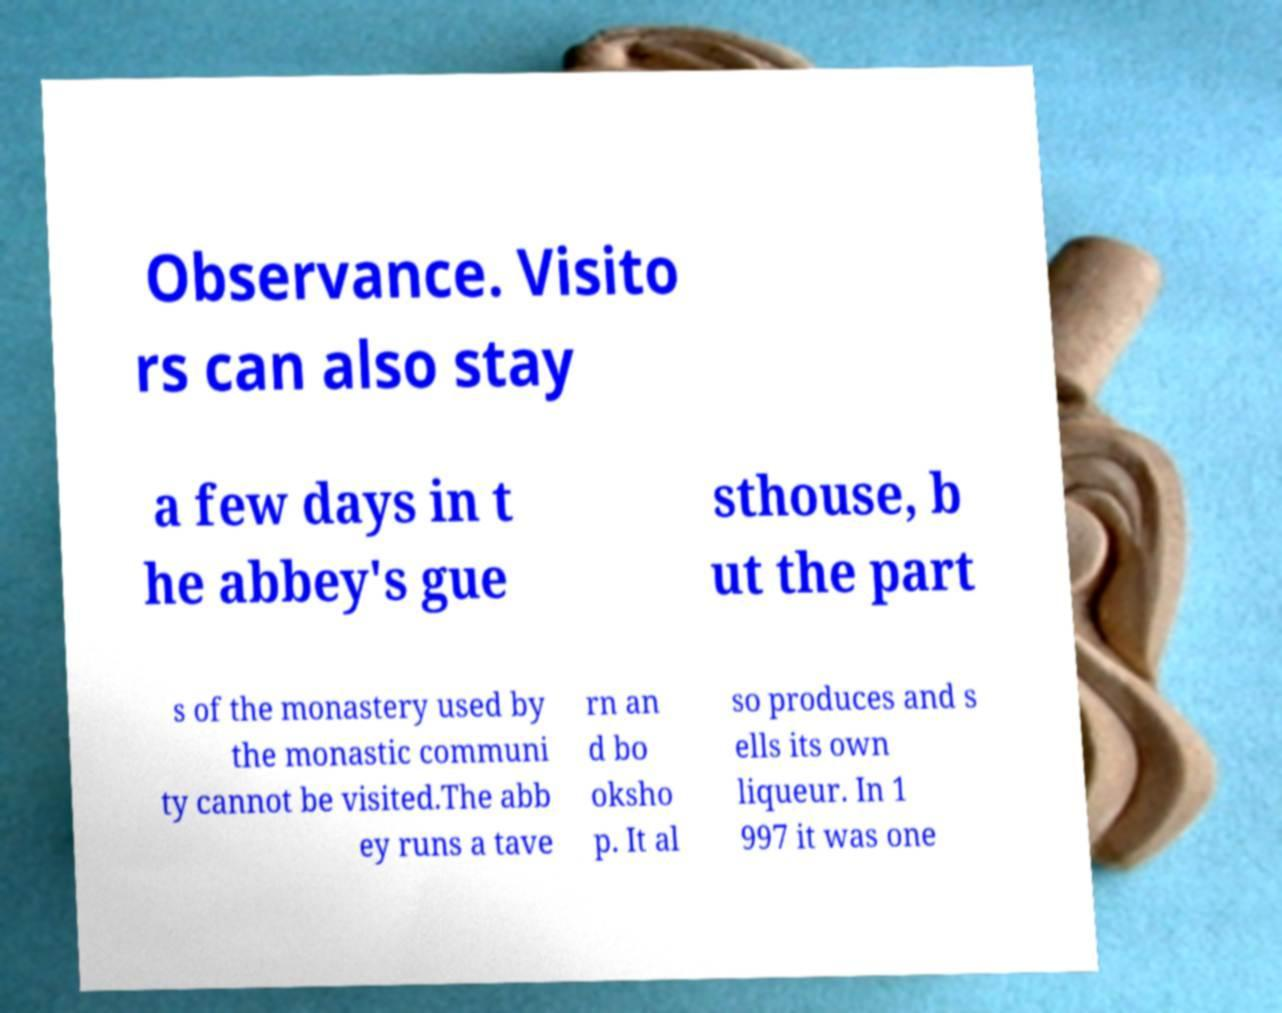Can you read and provide the text displayed in the image?This photo seems to have some interesting text. Can you extract and type it out for me? Observance. Visito rs can also stay a few days in t he abbey's gue sthouse, b ut the part s of the monastery used by the monastic communi ty cannot be visited.The abb ey runs a tave rn an d bo oksho p. It al so produces and s ells its own liqueur. In 1 997 it was one 